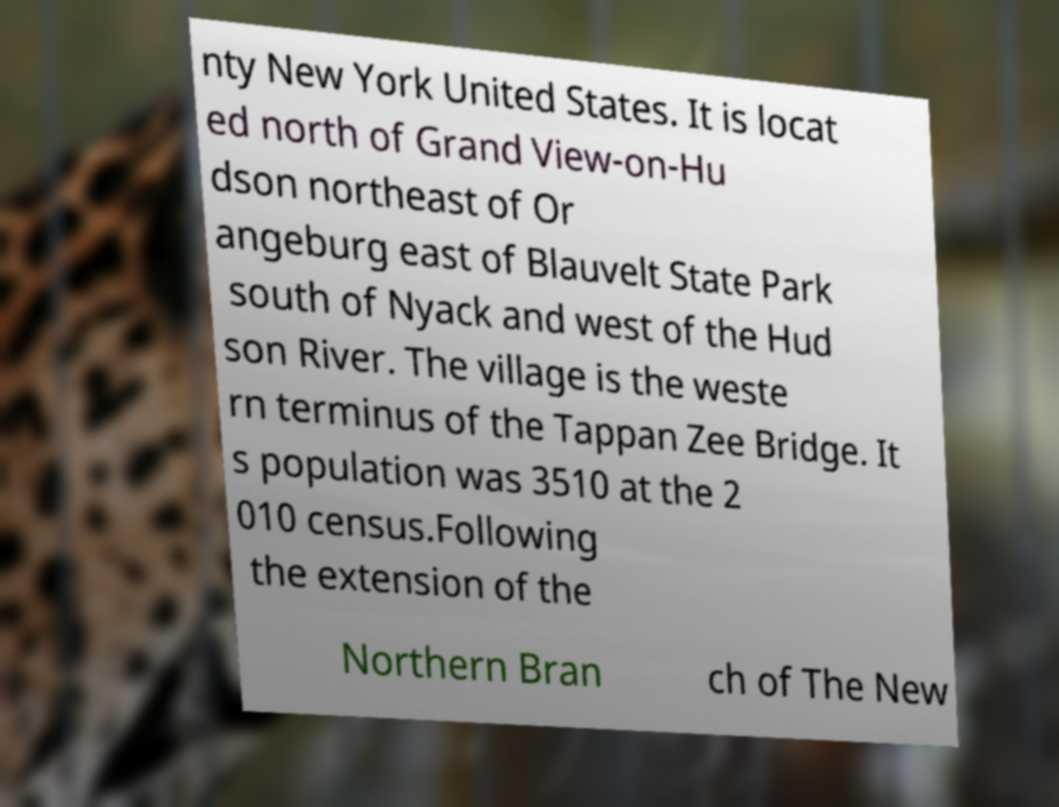Please identify and transcribe the text found in this image. nty New York United States. It is locat ed north of Grand View-on-Hu dson northeast of Or angeburg east of Blauvelt State Park south of Nyack and west of the Hud son River. The village is the weste rn terminus of the Tappan Zee Bridge. It s population was 3510 at the 2 010 census.Following the extension of the Northern Bran ch of The New 